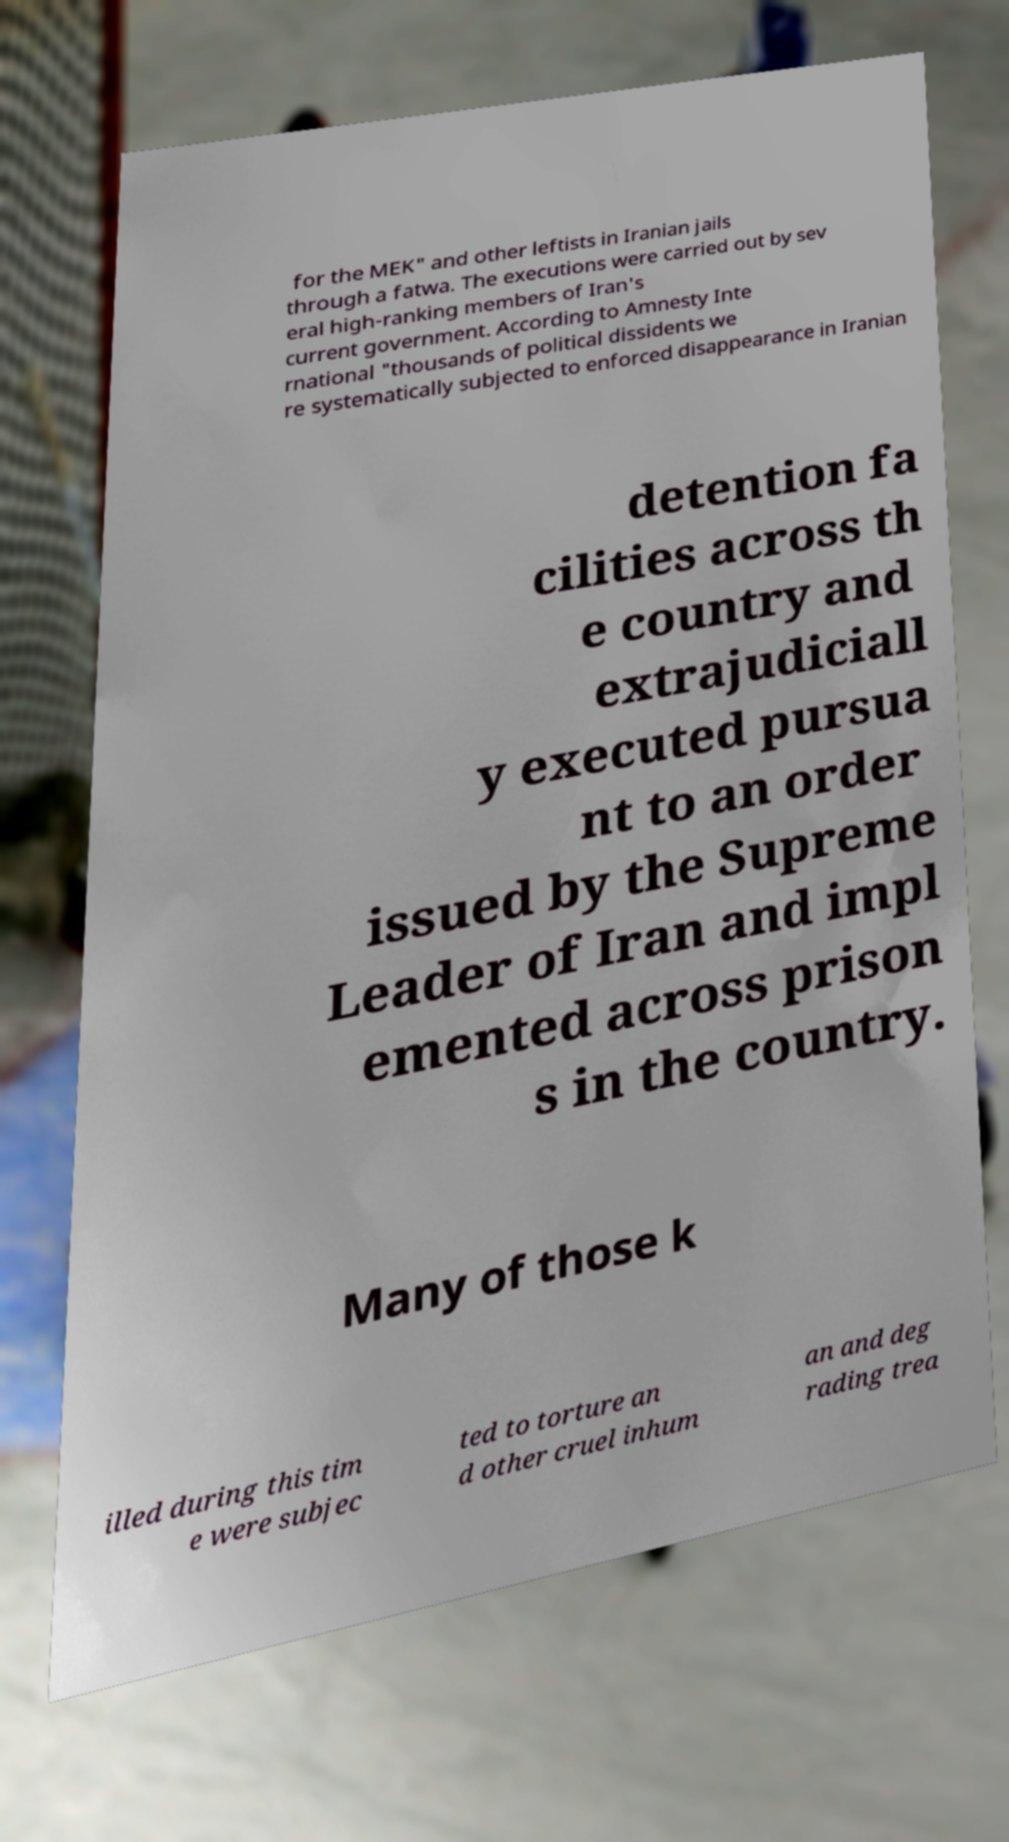Can you read and provide the text displayed in the image?This photo seems to have some interesting text. Can you extract and type it out for me? for the MEK" and other leftists in Iranian jails through a fatwa. The executions were carried out by sev eral high-ranking members of Iran's current government. According to Amnesty Inte rnational "thousands of political dissidents we re systematically subjected to enforced disappearance in Iranian detention fa cilities across th e country and extrajudiciall y executed pursua nt to an order issued by the Supreme Leader of Iran and impl emented across prison s in the country. Many of those k illed during this tim e were subjec ted to torture an d other cruel inhum an and deg rading trea 